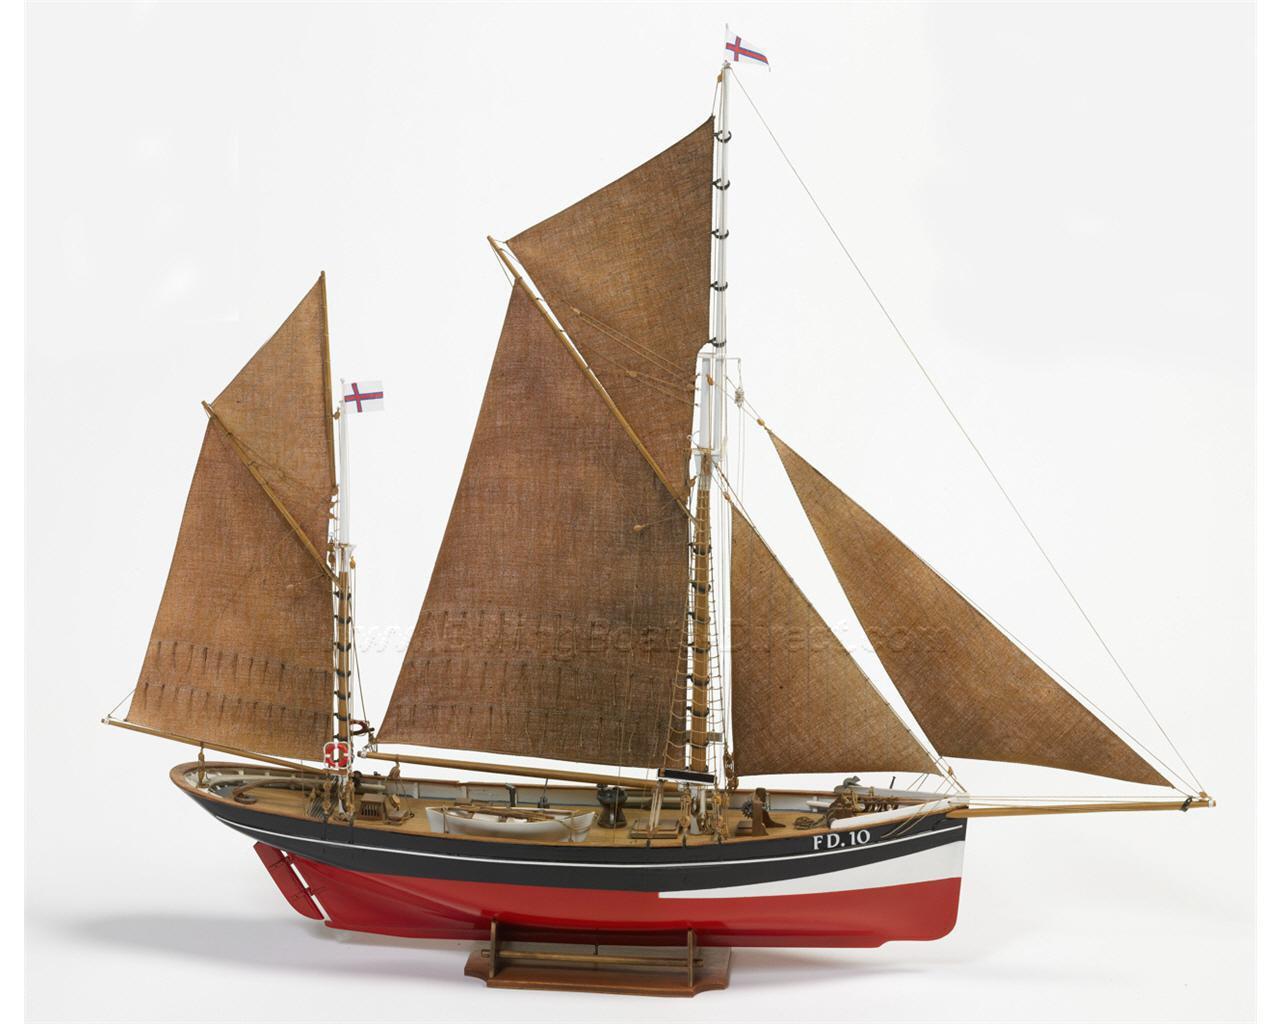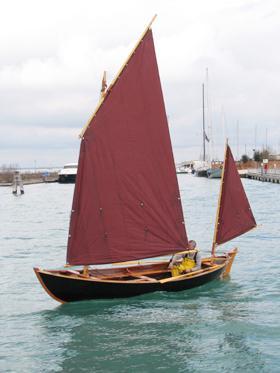The first image is the image on the left, the second image is the image on the right. For the images displayed, is the sentence "A boat has exactly two sails." factually correct? Answer yes or no. Yes. The first image is the image on the left, the second image is the image on the right. Given the left and right images, does the statement "A sailboat has only 1 large sail and 1 small sail unfurled." hold true? Answer yes or no. Yes. 